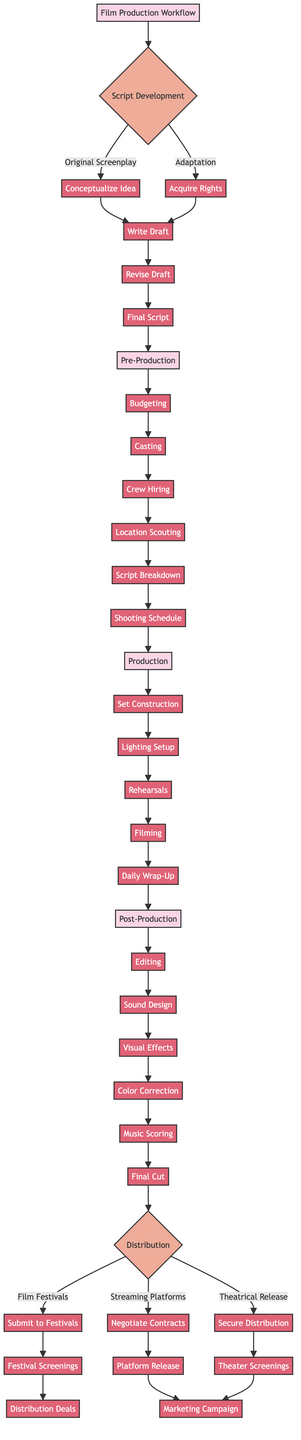What are the two options for Script Development? In the diagram, script development has two branches labeled "Original Screenplay" and "Adaptation."
Answer: Original Screenplay, Adaptation How many steps are there in the Pre-Production phase? The Pre-Production phase includes six steps: Budgeting, Casting, Crew Hiring, Location Scouting, Script Breakdown, and Shooting Schedule.
Answer: 6 What is the final step in the Production phase? Looking at the Production steps, the last one listed is "Daily Wrap-Up."
Answer: Daily Wrap-Up What comes after the Final Script in the workflow? The Final Script leads directly into the Pre-Production phase in the workflow.
Answer: Pre-Production Which option in Distribution has steps that include "Submit to Festivals"? The "Film Festivals" option includes the step "Submit to Festivals."
Answer: Film Festivals What are the three options available in the Distribution phase? The options listed in the Distribution phase are "Film Festivals," "Streaming Platforms," and "Theatrical Release."
Answer: Film Festivals, Streaming Platforms, Theatrical Release Which step in the Production phase follows Lighting Setup? After Lighting Setup, the next step is "Rehearsals."
Answer: Rehearsals How many total steps are in the Post-Production phase? The Post-Production phase includes six individual steps: Editing, Sound Design, Visual Effects, Color Correction, Music Scoring, and Final Cut, which totals to six steps.
Answer: 6 What is the first step in the Script Development section for Original Screenplay? The first step for an Original Screenplay is "Conceptualize Idea," which is outlined in the workflow.
Answer: Conceptualize Idea 